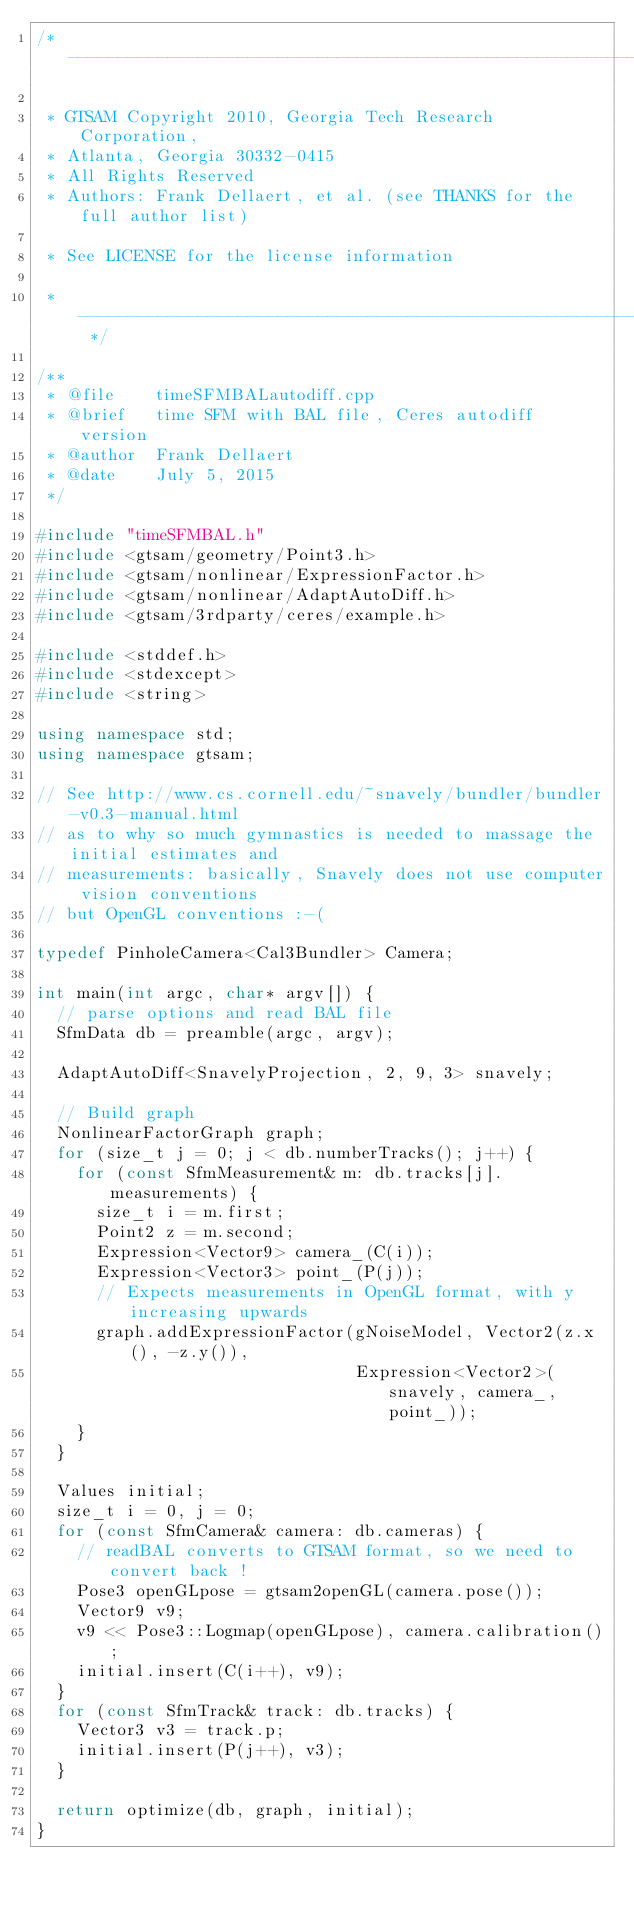<code> <loc_0><loc_0><loc_500><loc_500><_C++_>/* ----------------------------------------------------------------------------

 * GTSAM Copyright 2010, Georgia Tech Research Corporation,
 * Atlanta, Georgia 30332-0415
 * All Rights Reserved
 * Authors: Frank Dellaert, et al. (see THANKS for the full author list)

 * See LICENSE for the license information

 * -------------------------------------------------------------------------- */

/**
 * @file    timeSFMBALautodiff.cpp
 * @brief   time SFM with BAL file, Ceres autodiff version
 * @author  Frank Dellaert
 * @date    July 5, 2015
 */

#include "timeSFMBAL.h"
#include <gtsam/geometry/Point3.h>
#include <gtsam/nonlinear/ExpressionFactor.h>
#include <gtsam/nonlinear/AdaptAutoDiff.h>
#include <gtsam/3rdparty/ceres/example.h>

#include <stddef.h>
#include <stdexcept>
#include <string>

using namespace std;
using namespace gtsam;

// See http://www.cs.cornell.edu/~snavely/bundler/bundler-v0.3-manual.html
// as to why so much gymnastics is needed to massage the initial estimates and
// measurements: basically, Snavely does not use computer vision conventions
// but OpenGL conventions :-(

typedef PinholeCamera<Cal3Bundler> Camera;

int main(int argc, char* argv[]) {
  // parse options and read BAL file
  SfmData db = preamble(argc, argv);

  AdaptAutoDiff<SnavelyProjection, 2, 9, 3> snavely;

  // Build graph
  NonlinearFactorGraph graph;
  for (size_t j = 0; j < db.numberTracks(); j++) {
    for (const SfmMeasurement& m: db.tracks[j].measurements) {
      size_t i = m.first;
      Point2 z = m.second;
      Expression<Vector9> camera_(C(i));
      Expression<Vector3> point_(P(j));
      // Expects measurements in OpenGL format, with y increasing upwards
      graph.addExpressionFactor(gNoiseModel, Vector2(z.x(), -z.y()),
                                Expression<Vector2>(snavely, camera_, point_));
    }
  }

  Values initial;
  size_t i = 0, j = 0;
  for (const SfmCamera& camera: db.cameras) {
    // readBAL converts to GTSAM format, so we need to convert back !
    Pose3 openGLpose = gtsam2openGL(camera.pose());
    Vector9 v9;
    v9 << Pose3::Logmap(openGLpose), camera.calibration();
    initial.insert(C(i++), v9);
  }
  for (const SfmTrack& track: db.tracks) {
    Vector3 v3 = track.p;
    initial.insert(P(j++), v3);
  }

  return optimize(db, graph, initial);
}
</code> 